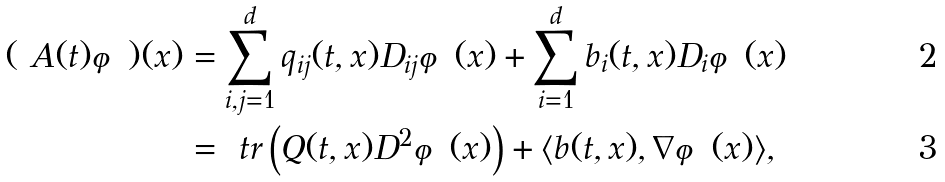Convert formula to latex. <formula><loc_0><loc_0><loc_500><loc_500>( \ A ( t ) \varphi ) ( x ) & = \sum _ { i , j = 1 } ^ { d } q _ { i j } ( t , x ) D _ { i j } \varphi ( x ) + \sum _ { i = 1 } ^ { d } b _ { i } ( t , x ) D _ { i } \varphi ( x ) \\ & = \ t r \left ( Q ( t , x ) D ^ { 2 } \varphi ( x ) \right ) + \langle b ( t , x ) , \nabla \varphi ( x ) \rangle ,</formula> 